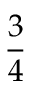Convert formula to latex. <formula><loc_0><loc_0><loc_500><loc_500>\frac { 3 } { 4 }</formula> 